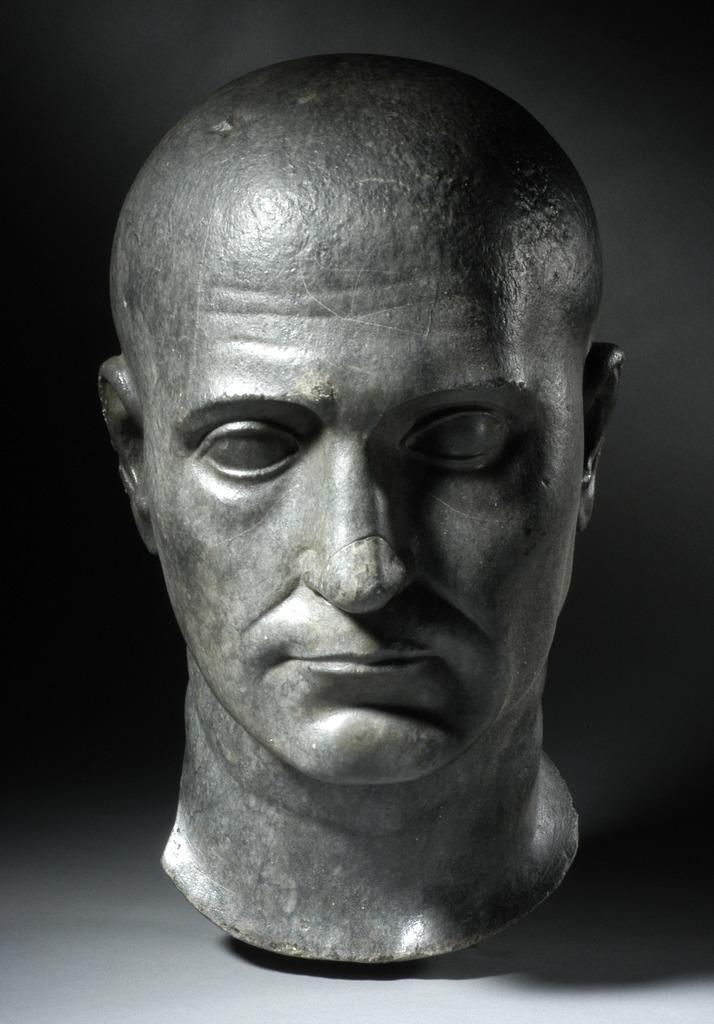How would you summarize this image in a sentence or two? In this image there is a sculpture of a person's face on the ground, the background of the image is dark. 